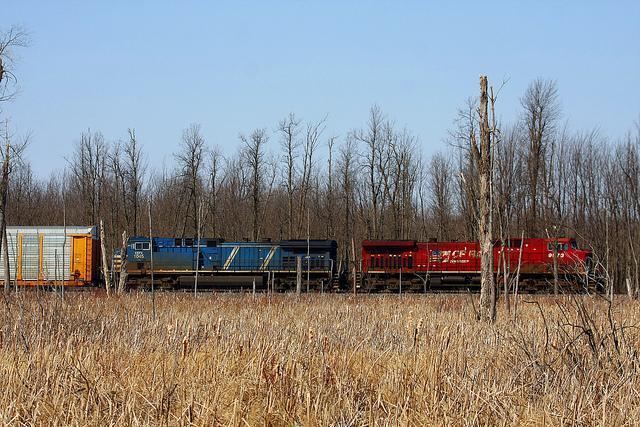How many trains are in the picture?
Give a very brief answer. 2. 